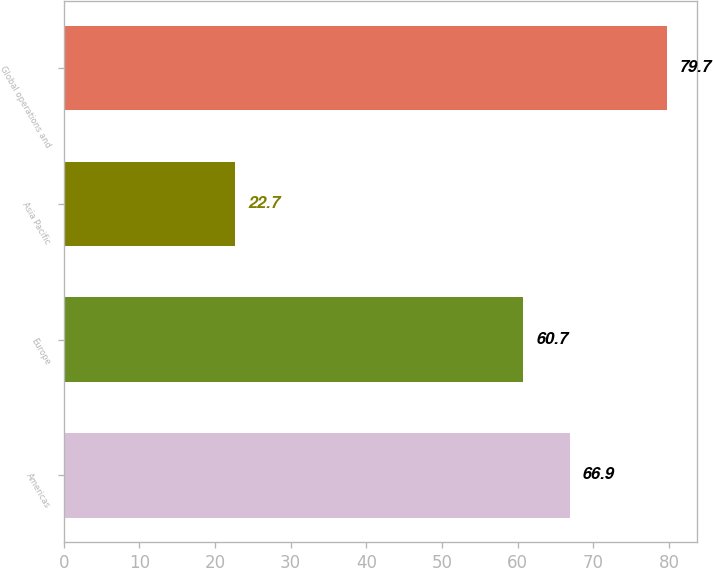Convert chart to OTSL. <chart><loc_0><loc_0><loc_500><loc_500><bar_chart><fcel>Americas<fcel>Europe<fcel>Asia Pacific<fcel>Global operations and<nl><fcel>66.9<fcel>60.7<fcel>22.7<fcel>79.7<nl></chart> 